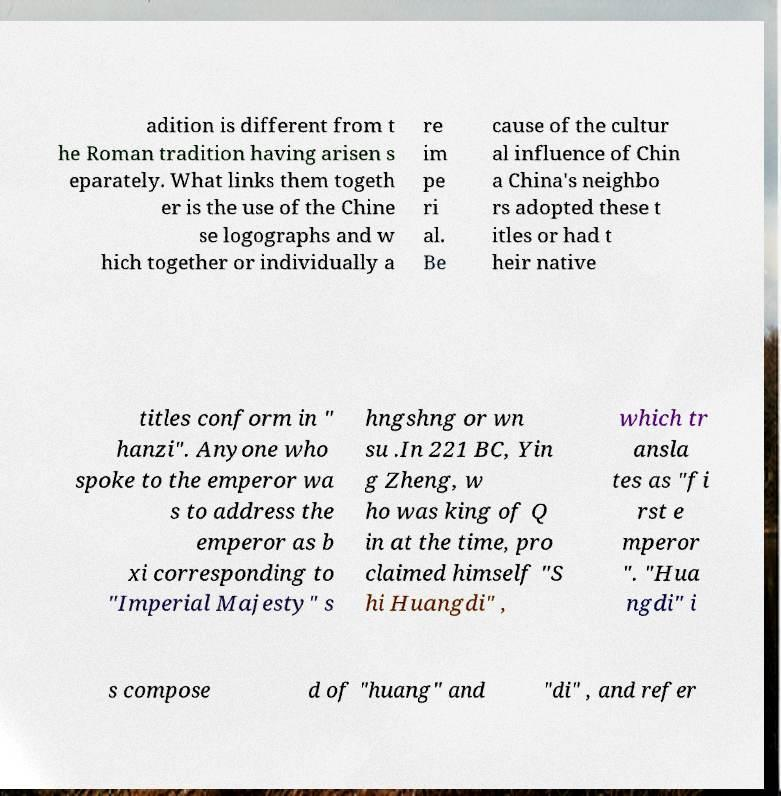There's text embedded in this image that I need extracted. Can you transcribe it verbatim? adition is different from t he Roman tradition having arisen s eparately. What links them togeth er is the use of the Chine se logographs and w hich together or individually a re im pe ri al. Be cause of the cultur al influence of Chin a China's neighbo rs adopted these t itles or had t heir native titles conform in " hanzi". Anyone who spoke to the emperor wa s to address the emperor as b xi corresponding to "Imperial Majesty" s hngshng or wn su .In 221 BC, Yin g Zheng, w ho was king of Q in at the time, pro claimed himself "S hi Huangdi" , which tr ansla tes as "fi rst e mperor ". "Hua ngdi" i s compose d of "huang" and "di" , and refer 